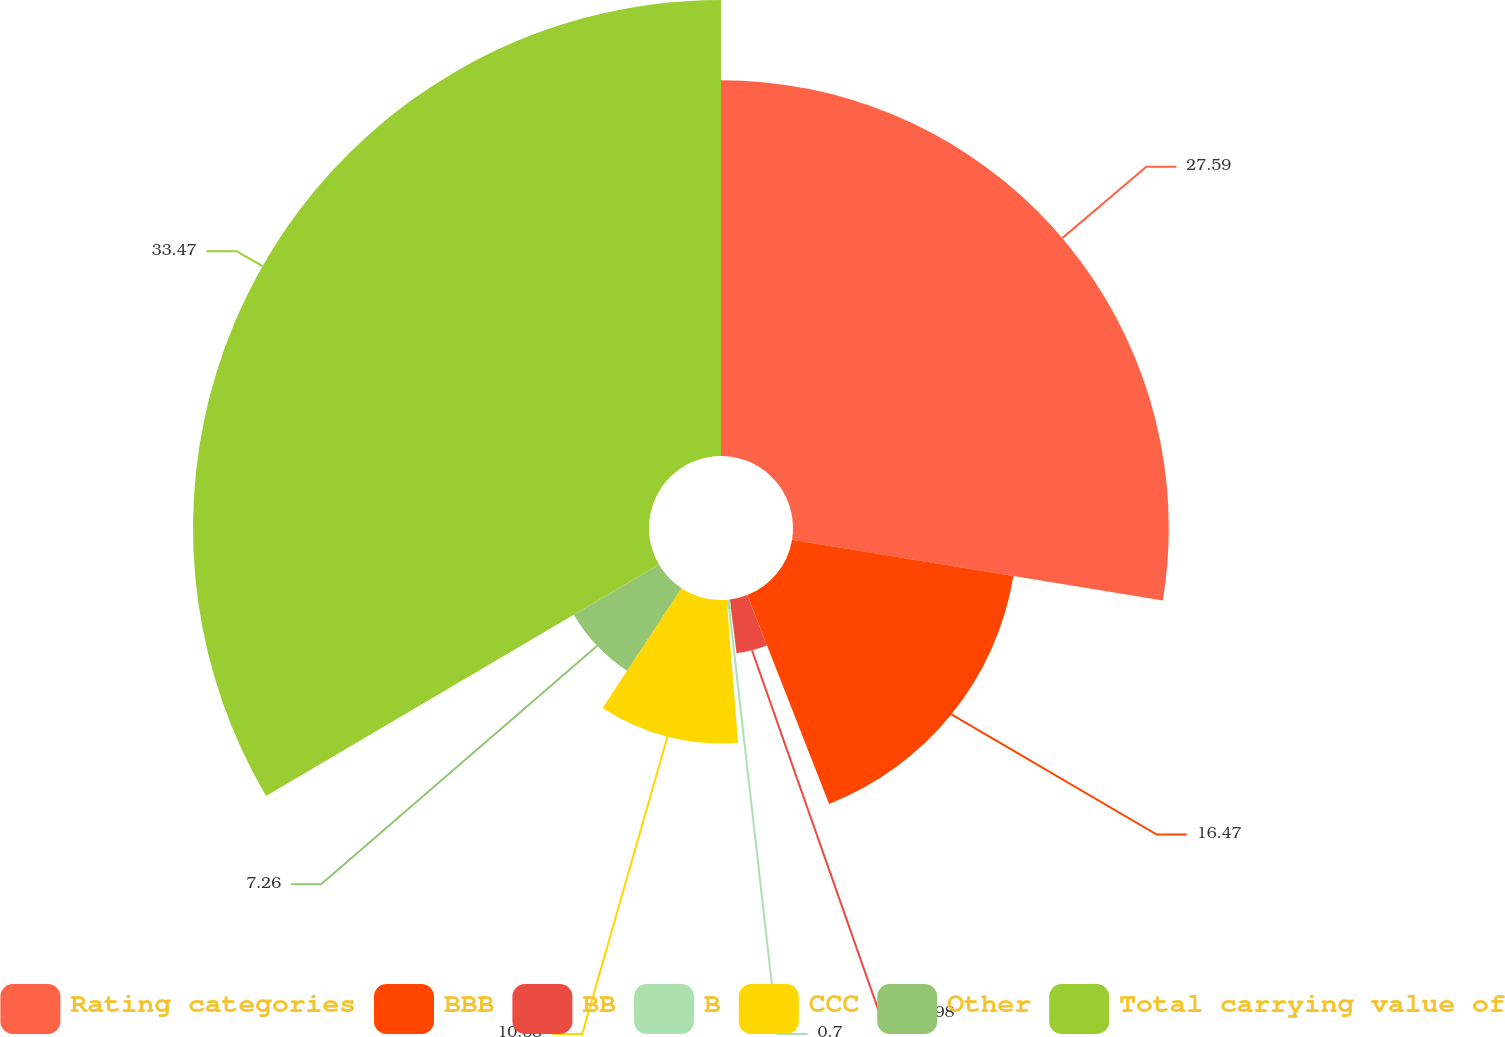<chart> <loc_0><loc_0><loc_500><loc_500><pie_chart><fcel>Rating categories<fcel>BBB<fcel>BB<fcel>B<fcel>CCC<fcel>Other<fcel>Total carrying value of<nl><fcel>27.59%<fcel>16.47%<fcel>3.98%<fcel>0.7%<fcel>10.53%<fcel>7.26%<fcel>33.48%<nl></chart> 